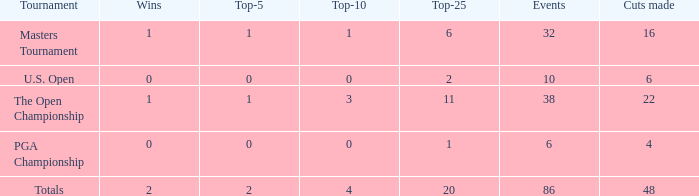Provide the total quantity of top 25 for wins fewer than 1 and 22 cuts made. 0.0. 